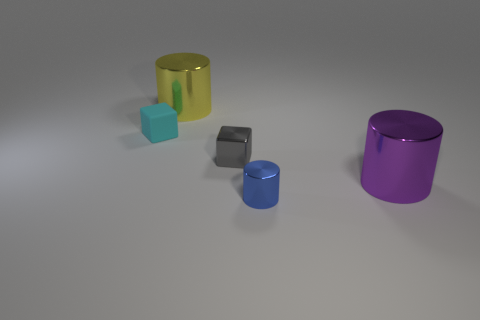Add 4 big purple metallic things. How many objects exist? 9 Subtract all cylinders. How many objects are left? 2 Subtract 0 red cylinders. How many objects are left? 5 Subtract all tiny gray metal spheres. Subtract all big purple things. How many objects are left? 4 Add 2 tiny blue shiny cylinders. How many tiny blue shiny cylinders are left? 3 Add 4 small green metallic things. How many small green metallic things exist? 4 